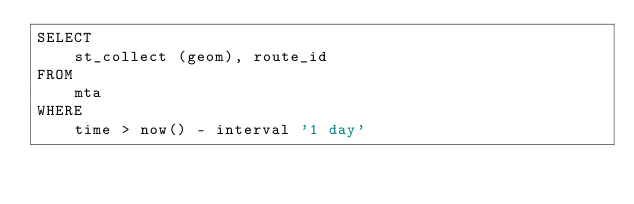Convert code to text. <code><loc_0><loc_0><loc_500><loc_500><_SQL_>SELECT
    st_collect (geom), route_id
FROM
    mta
WHERE
    time > now() - interval '1 day'</code> 